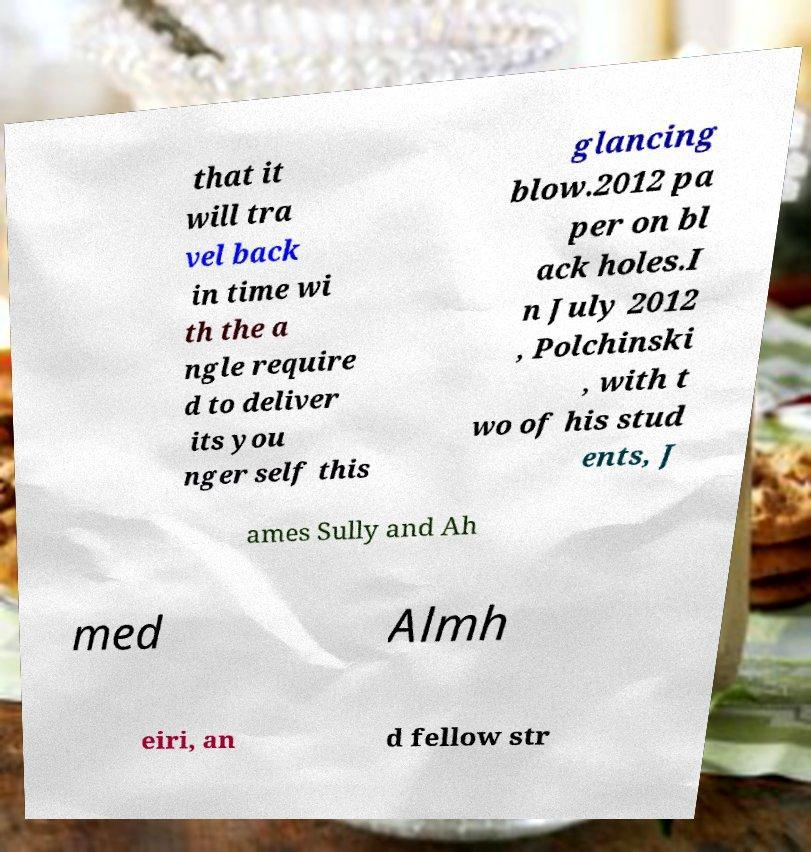Could you assist in decoding the text presented in this image and type it out clearly? that it will tra vel back in time wi th the a ngle require d to deliver its you nger self this glancing blow.2012 pa per on bl ack holes.I n July 2012 , Polchinski , with t wo of his stud ents, J ames Sully and Ah med Almh eiri, an d fellow str 